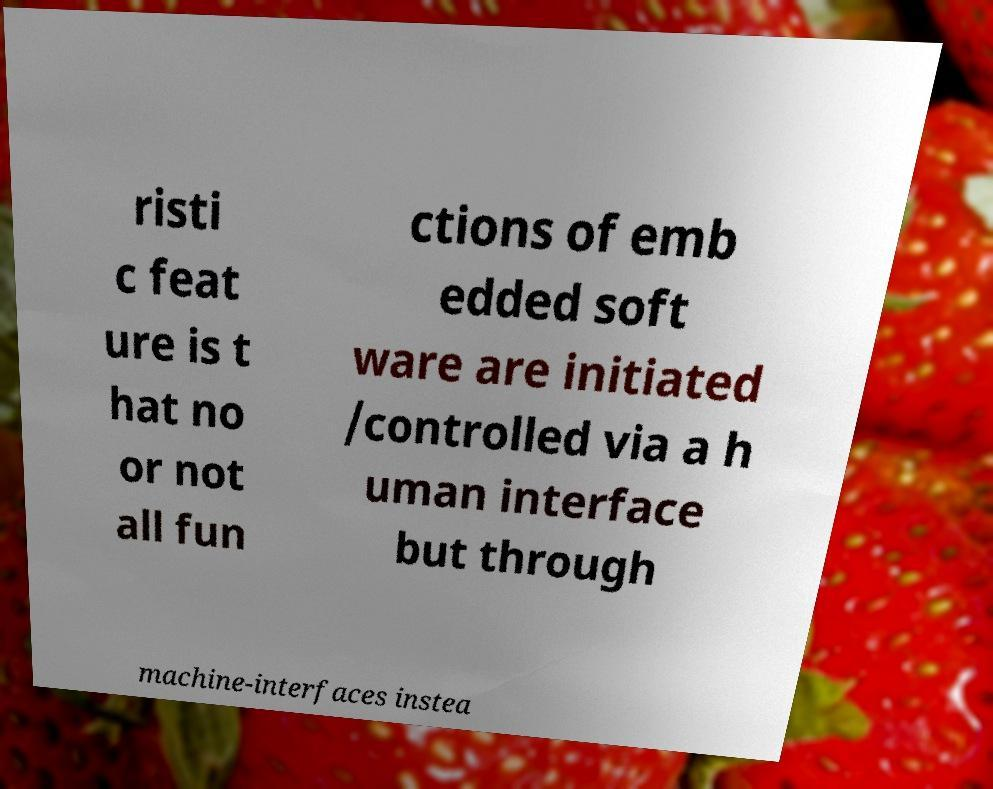Please read and relay the text visible in this image. What does it say? risti c feat ure is t hat no or not all fun ctions of emb edded soft ware are initiated /controlled via a h uman interface but through machine-interfaces instea 